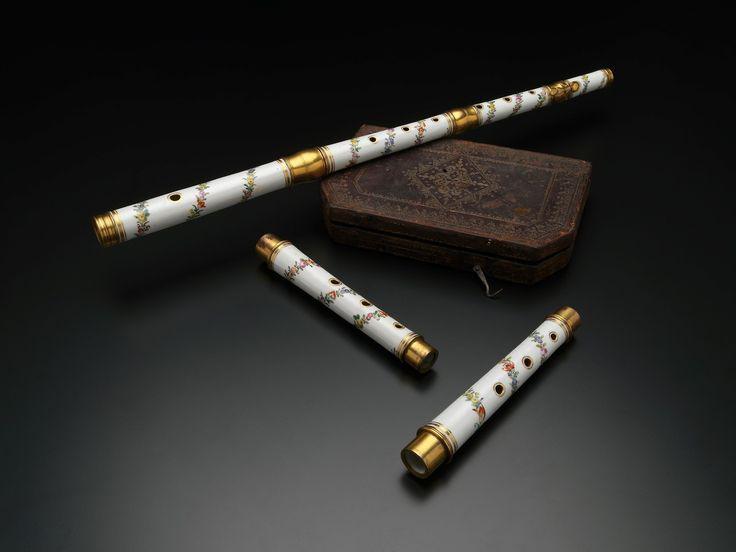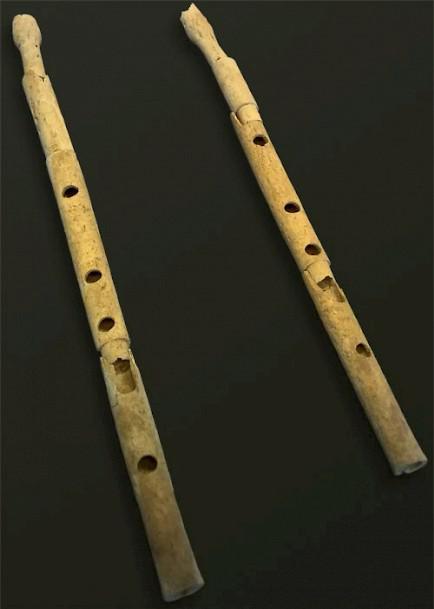The first image is the image on the left, the second image is the image on the right. Given the left and right images, does the statement "One image shows a single flute displayed diagonally, and the other image shows at least two flutes displayed right next to each other diagonally." hold true? Answer yes or no. No. The first image is the image on the left, the second image is the image on the right. Evaluate the accuracy of this statement regarding the images: "Two light colored flutes sit side by side.". Is it true? Answer yes or no. Yes. 